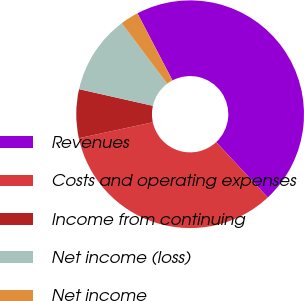<chart> <loc_0><loc_0><loc_500><loc_500><pie_chart><fcel>Revenues<fcel>Costs and operating expenses<fcel>Income from continuing<fcel>Net income (loss)<fcel>Net income<nl><fcel>45.71%<fcel>33.57%<fcel>6.91%<fcel>11.22%<fcel>2.59%<nl></chart> 